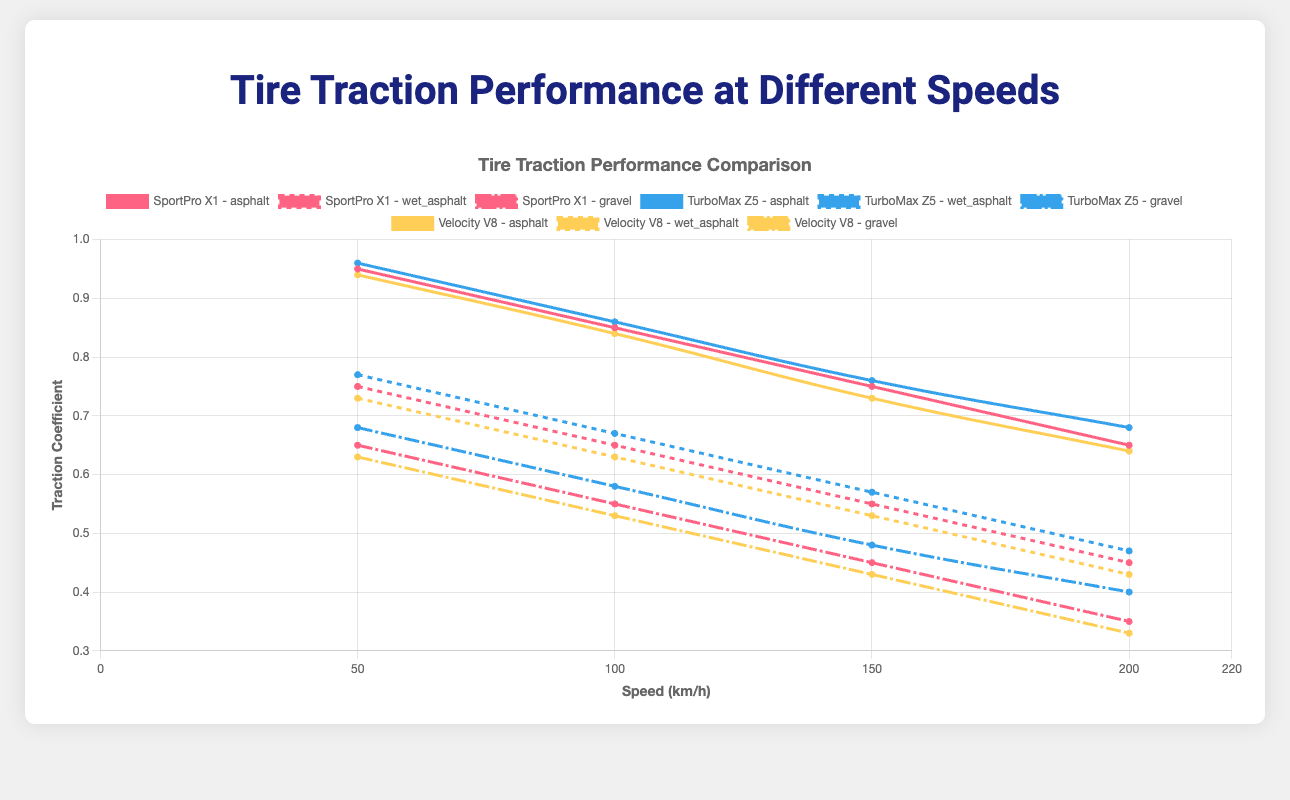Which road surface shows the highest traction coefficient for the SportPro X1 at 50 km/h? Observe the plotted data points at 50 km/h for SportPro X1 across different road surfaces. The traction coefficients at 50 km/h are 0.95 for asphalt, 0.75 for wet_asphalt, and 0.65 for gravel. The highest value is 0.95 on asphalt.
Answer: Asphalt Which tire model has the best traction performance on gravel at lower speeds? Compare the traction coefficients at 50 km/h for the models on gravel. SportPro X1 has 0.65, TurboMax Z5 has 0.68, and Velocity V8 has 0.63. TurboMax Z5 shows the highest traction coefficient at lower speeds.
Answer: TurboMax Z5 What’s the difference in traction coefficient for SportPro X1 on asphalt between 100 km/h and 200 km/h? Look at the values at 100 km/h (0.85) and 200 km/h (0.65) for SportPro X1 on asphalt. The difference is calculated as 0.85 - 0.65 = 0.20.
Answer: 0.20 Which model experiences the largest decrease in traction coefficient from 50 km/h to 200 km/h on wet asphalt? Calculate the decrease for each model on wet asphalt. For SportPro X1: 0.75 - 0.45 = 0.30, TurboMax Z5: 0.77 - 0.47 = 0.30, and Velocity V8: 0.73 - 0.43 = 0.30. All three models experience the same decrease.
Answer: SportPro X1, TurboMax Z5, Velocity V8 At 150 km/h, which model has the best traction performance on asphalt? Compare the traction coefficients for 150 km/h on asphalt. SportPro X1: 0.75, TurboMax Z5: 0.76, and Velocity V8: 0.73. TurboMax Z5 has the highest traction coefficient.
Answer: TurboMax Z5 On which road surface does the Velocity V8 show the steepest decline in traction coefficient from 50 km/h to 200 km/h? Calculate the decline for each surface: Asphalt: 0.94 - 0.64 = 0.30, Wet Asphalt: 0.73 - 0.43 = 0.30, Gravel: 0.63 - 0.33 = 0.30. The decline is the same across all surfaces.
Answer: Asphalt, Wet Asphalt, Gravel How does the traction performance of TurboMax Z5 on gravel at 200 km/h compare to its performance on asphalt at the same speed? Compare the traction coefficients for TurboMax Z5 at 200 km/h on gravel (0.40) and asphalt (0.68). The traction on asphalt is higher by 0.28.
Answer: Asphalt is higher by 0.28 What is the average traction coefficient of Velocity V8 on wet asphalt across all speeds? Compute the average by summing the traction coefficients and dividing by the number of points: (0.73 + 0.63 + 0.53 + 0.43) / 4 = 2.32 / 4 = 0.58.
Answer: 0.58 Which model shows the most consistent traction coefficient on asphalt across different speeds? Assess the rate of change in traction coefficients for each model on asphalt. SportPro X1: (0.95 - 0.85) + (0.85 - 0.75) + (0.75 - 0.65) = 0.30. TurboMax Z5: (0.96 - 0.86) + (0.86 - 0.76) + (0.76 - 0.68) = 0.30. Velocity V8: (0.94 - 0.84) + (0.84 - 0.73) + (0.73 - 0.64) = 0.31. TurboMax Z5 and SportPro X1 show the most consistent performance.
Answer: TurboMax Z5, SportPro X1 